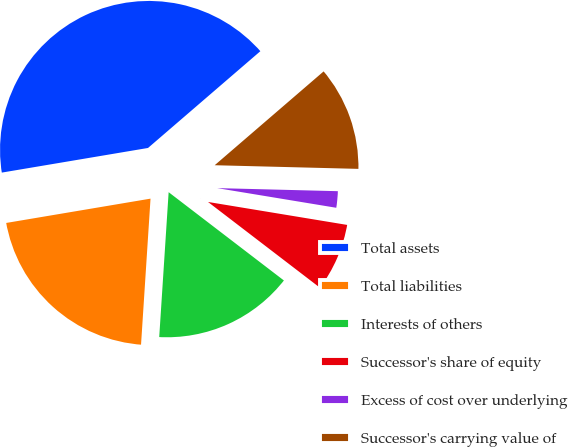<chart> <loc_0><loc_0><loc_500><loc_500><pie_chart><fcel>Total assets<fcel>Total liabilities<fcel>Interests of others<fcel>Successor's share of equity<fcel>Excess of cost over underlying<fcel>Successor's carrying value of<nl><fcel>41.34%<fcel>21.31%<fcel>15.63%<fcel>7.8%<fcel>2.2%<fcel>11.72%<nl></chart> 